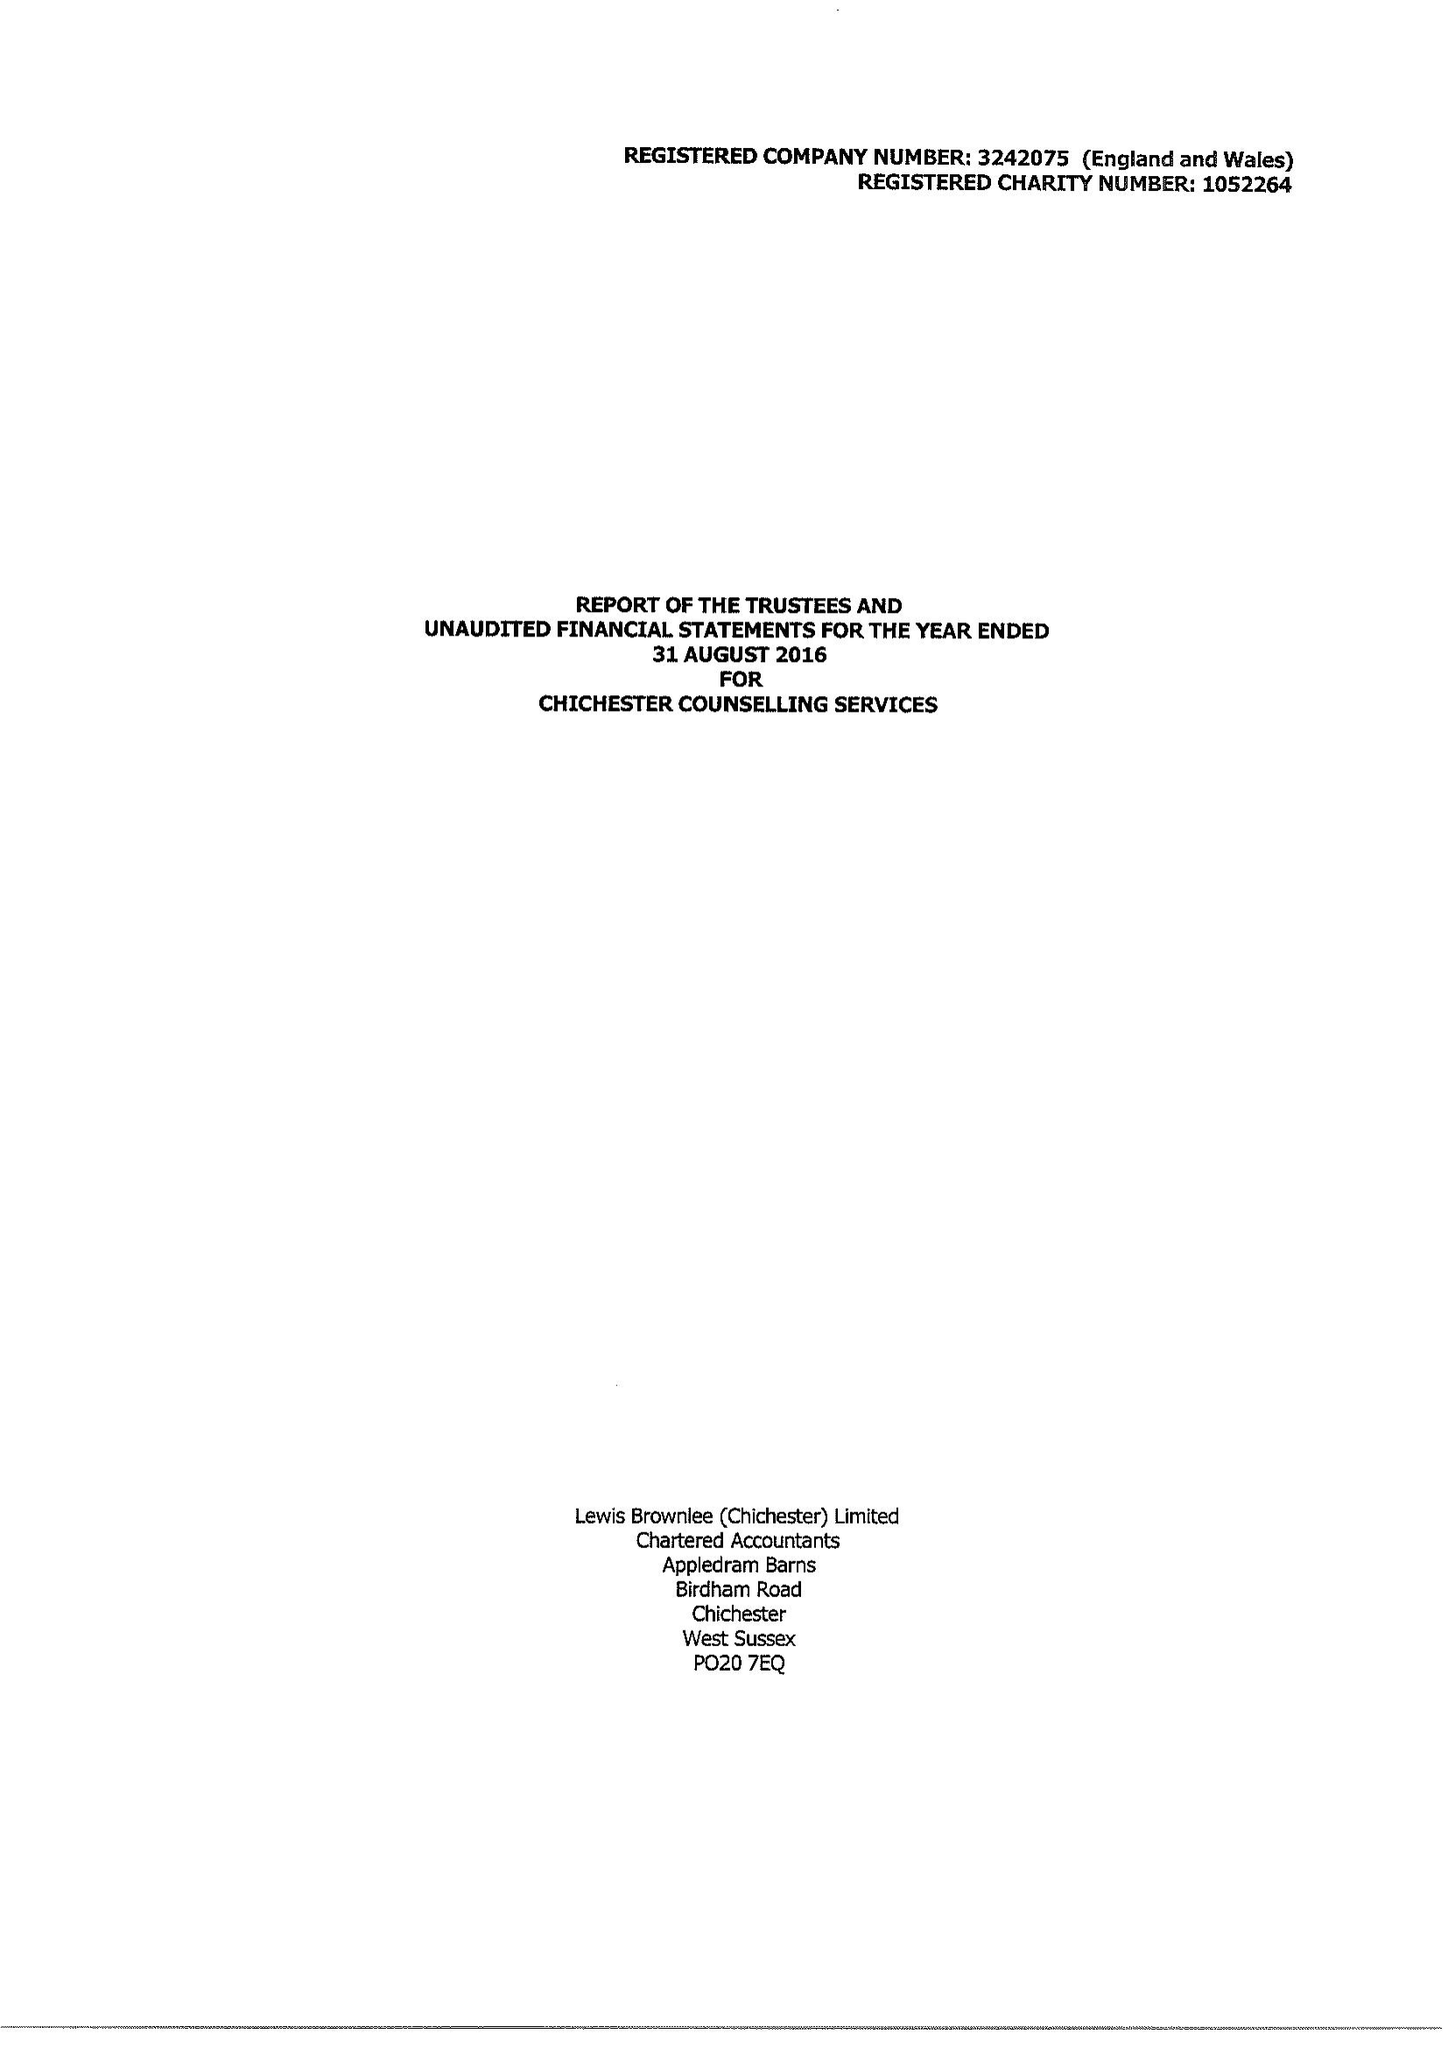What is the value for the spending_annually_in_british_pounds?
Answer the question using a single word or phrase. 156049.00 